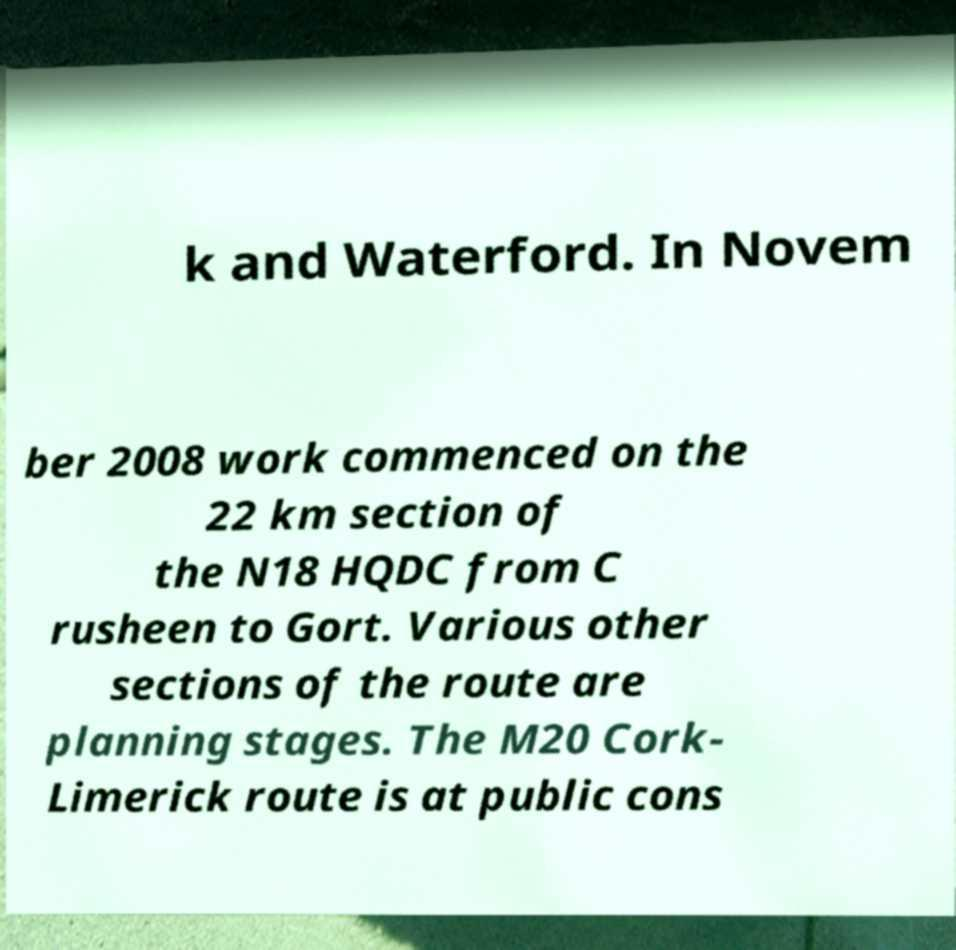Could you assist in decoding the text presented in this image and type it out clearly? k and Waterford. In Novem ber 2008 work commenced on the 22 km section of the N18 HQDC from C rusheen to Gort. Various other sections of the route are planning stages. The M20 Cork- Limerick route is at public cons 